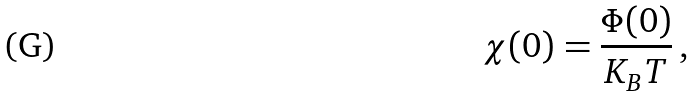<formula> <loc_0><loc_0><loc_500><loc_500>\chi ( 0 ) = \frac { \Phi ( 0 ) } { K _ { B } T } \, ,</formula> 